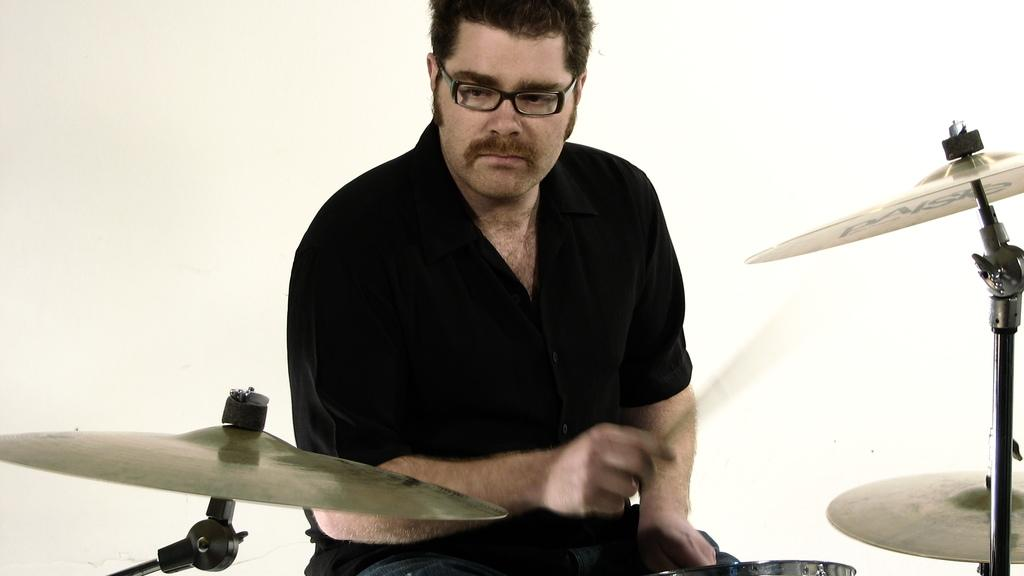What is the man in the image doing? The man is sitting in the image. What is the man wearing? The man is wearing clothes and spectacles. What is the man holding in his hand? The man is holding drumsticks in his hand. What can be seen in the image besides the man? There is a musical instrument in the image. What is the color of the background in the image? The background of the image is white. How many rings can be seen on the man's finger in the image? There is no ring visible on the man's finger in the image. What type of point is the man trying to make with the drumsticks in the image? The image does not provide any information about the man's intentions or actions with the drumsticks, so it cannot be determined if he is trying to make a point. 